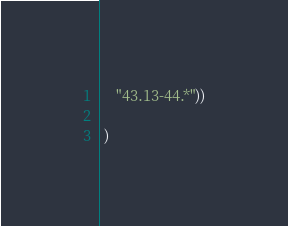Convert code to text. <code><loc_0><loc_0><loc_500><loc_500><_Lisp_>    "43.13-44.*"))

 )
</code> 